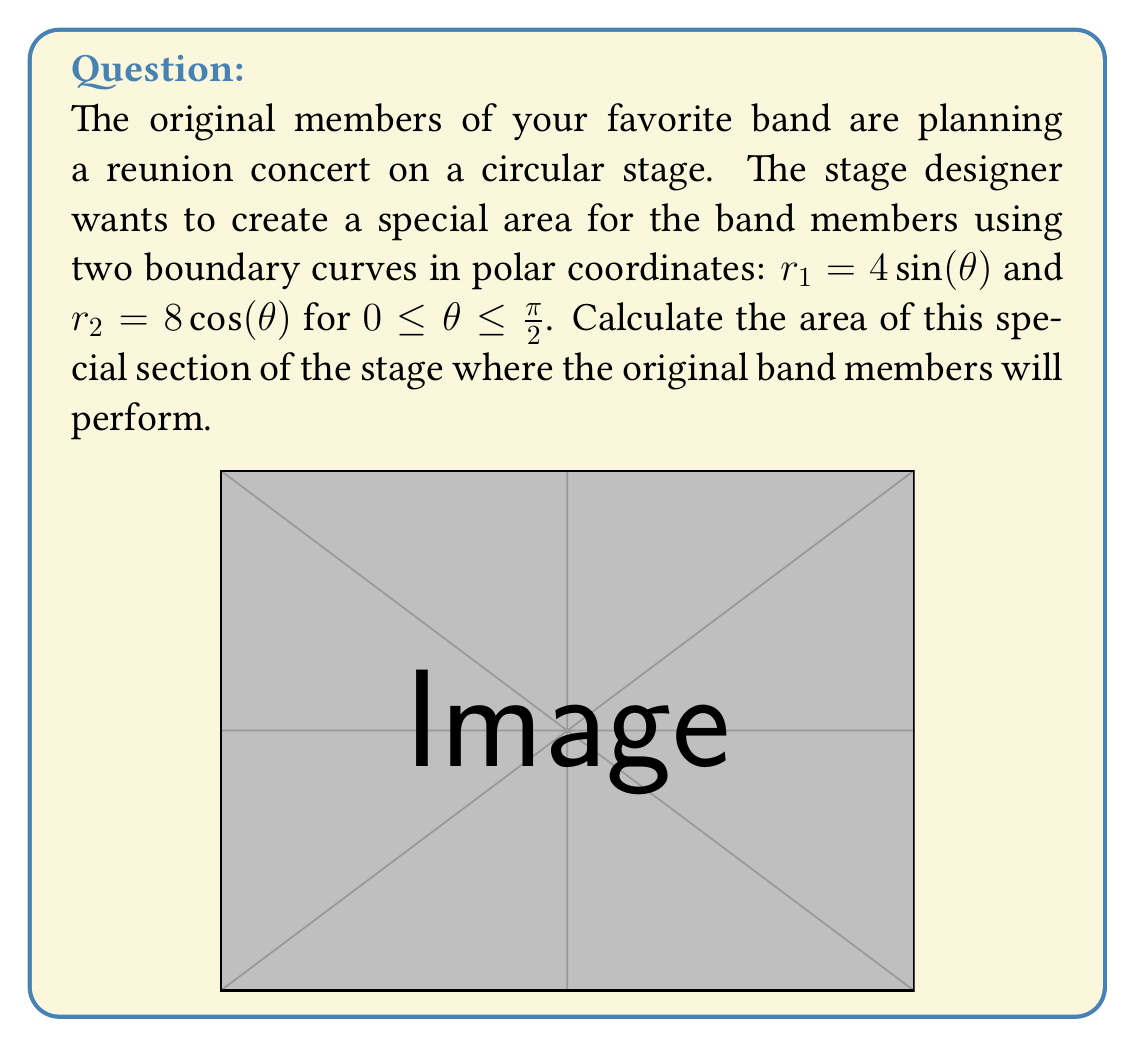Solve this math problem. To calculate the area between two polar curves, we use the formula:

$$ A = \frac{1}{2} \int_a^b [r_2(\theta)^2 - r_1(\theta)^2] d\theta $$

Where $r_2(\theta)$ is the outer curve and $r_1(\theta)$ is the inner curve.

Step 1: Set up the integral
$$ A = \frac{1}{2} \int_0^{\frac{\pi}{2}} [(8\cos(\theta))^2 - (4\sin(\theta))^2] d\theta $$

Step 2: Simplify the integrand
$$ A = \frac{1}{2} \int_0^{\frac{\pi}{2}} [64\cos^2(\theta) - 16\sin^2(\theta)] d\theta $$

Step 3: Use the identity $\sin^2(\theta) + \cos^2(\theta) = 1$ to rewrite $\sin^2(\theta)$
$$ A = \frac{1}{2} \int_0^{\frac{\pi}{2}} [64\cos^2(\theta) - 16(1-\cos^2(\theta))] d\theta $$
$$ A = \frac{1}{2} \int_0^{\frac{\pi}{2}} [64\cos^2(\theta) - 16 + 16\cos^2(\theta)] d\theta $$
$$ A = \frac{1}{2} \int_0^{\frac{\pi}{2}} [80\cos^2(\theta) - 16] d\theta $$

Step 4: Integrate
$$ A = \frac{1}{2} [80(\frac{\theta}{2} + \frac{\sin(2\theta)}{4}) - 16\theta]_0^{\frac{\pi}{2}} $$

Step 5: Evaluate the integral
$$ A = \frac{1}{2} [(80(\frac{\pi}{4} + 0) - 8\pi) - (0 - 0)] $$
$$ A = \frac{1}{2} [20\pi - 8\pi] $$
$$ A = \frac{1}{2} [12\pi] $$
$$ A = 6\pi $$

Therefore, the area of the special section of the stage is $6\pi$ square units.
Answer: $6\pi$ square units 